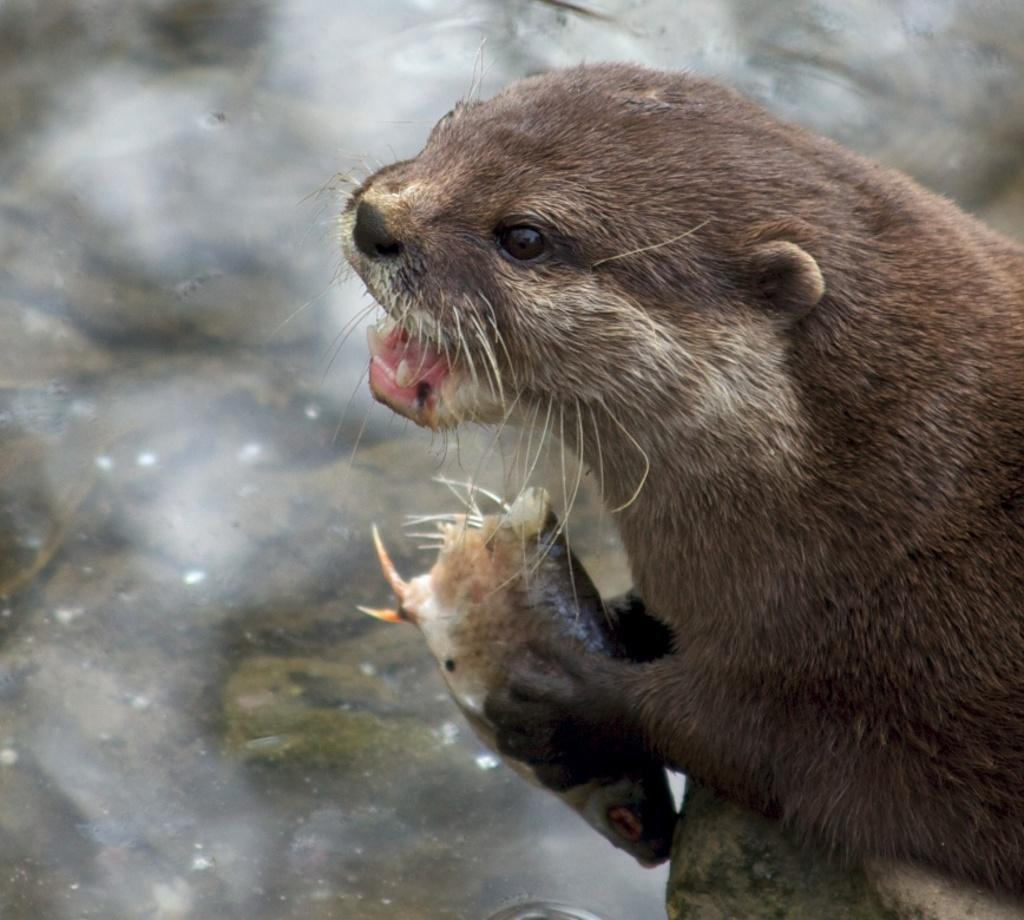What type of creature is present in the image? There is an animal in the image. What is the animal doing in the image? The animal is holding something in its hand. What can be seen in the background of the image? There is water visible in the image. What type of yoke can be seen in the image? There is no yoke present in the image. 